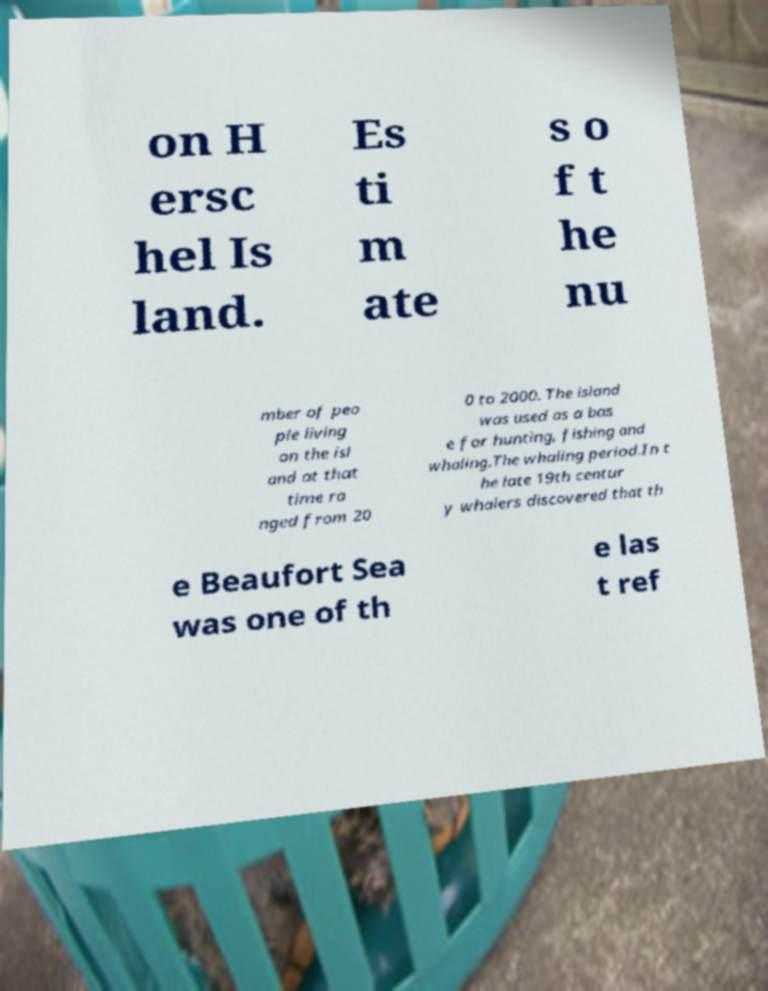Can you read and provide the text displayed in the image?This photo seems to have some interesting text. Can you extract and type it out for me? on H ersc hel Is land. Es ti m ate s o f t he nu mber of peo ple living on the isl and at that time ra nged from 20 0 to 2000. The island was used as a bas e for hunting, fishing and whaling.The whaling period.In t he late 19th centur y whalers discovered that th e Beaufort Sea was one of th e las t ref 